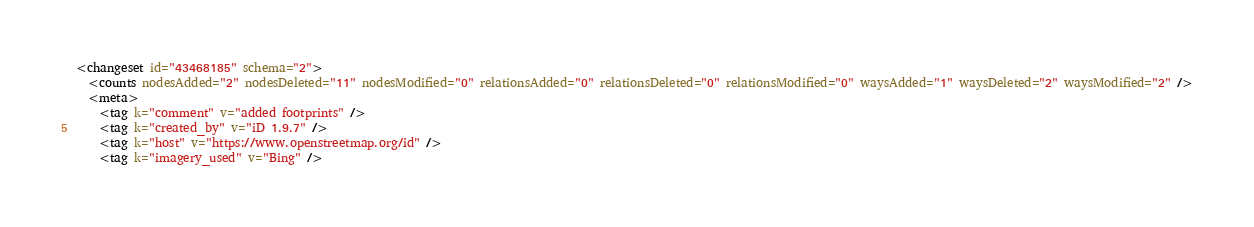<code> <loc_0><loc_0><loc_500><loc_500><_XML_><changeset id="43468185" schema="2">
  <counts nodesAdded="2" nodesDeleted="11" nodesModified="0" relationsAdded="0" relationsDeleted="0" relationsModified="0" waysAdded="1" waysDeleted="2" waysModified="2" />
  <meta>
    <tag k="comment" v="added footprints" />
    <tag k="created_by" v="iD 1.9.7" />
    <tag k="host" v="https://www.openstreetmap.org/id" />
    <tag k="imagery_used" v="Bing" /></code> 